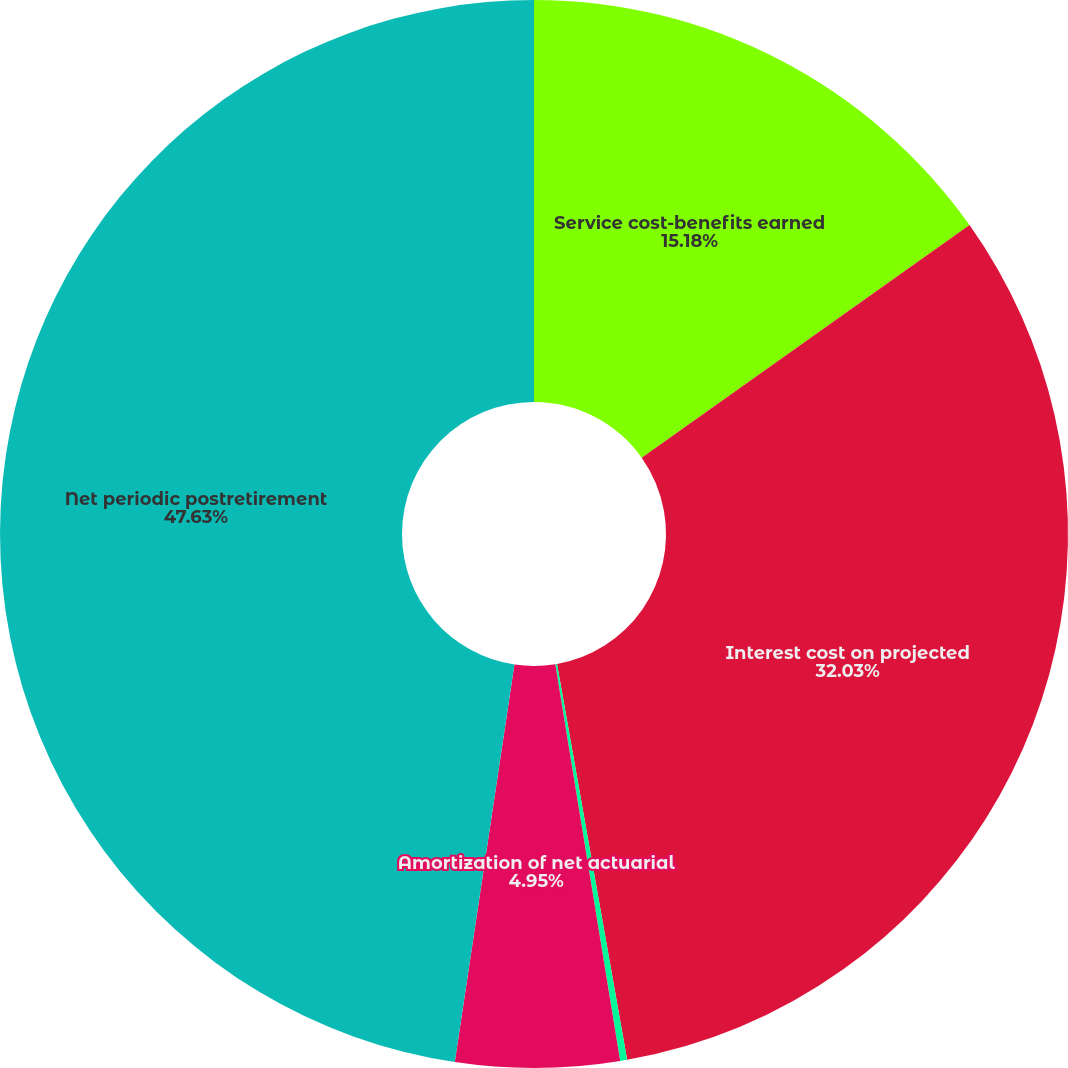<chart> <loc_0><loc_0><loc_500><loc_500><pie_chart><fcel>Service cost-benefits earned<fcel>Interest cost on projected<fcel>Amortization of prior service<fcel>Amortization of net actuarial<fcel>Net periodic postretirement<nl><fcel>15.18%<fcel>32.03%<fcel>0.21%<fcel>4.95%<fcel>47.63%<nl></chart> 